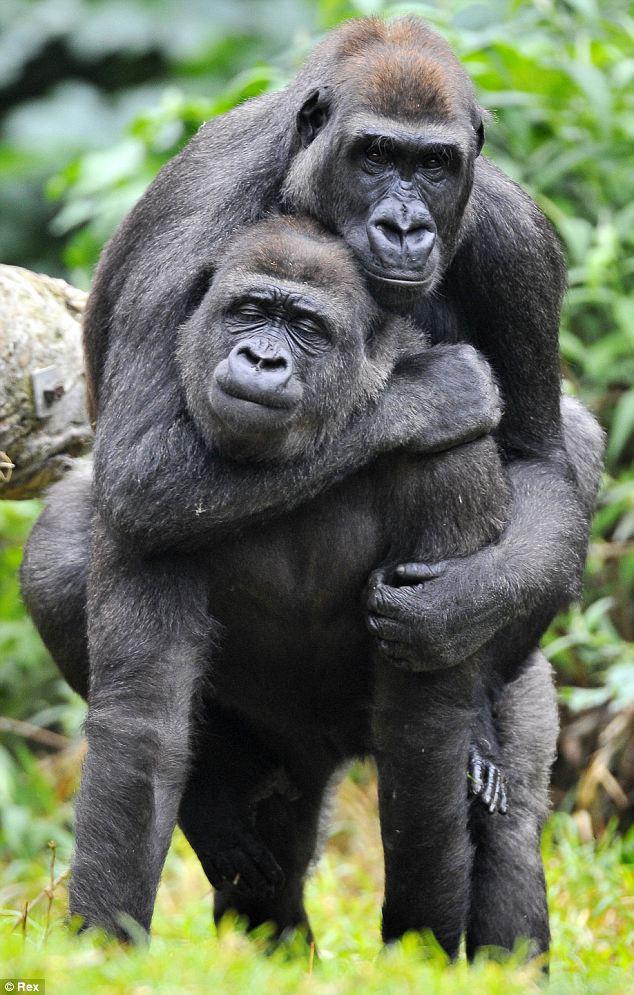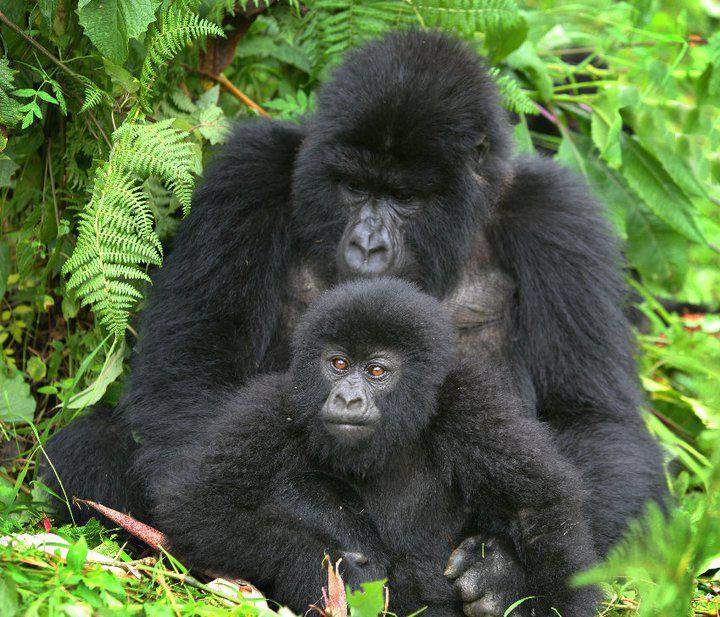The first image is the image on the left, the second image is the image on the right. For the images shown, is this caption "There are two animals in the image on the left." true? Answer yes or no. Yes. 